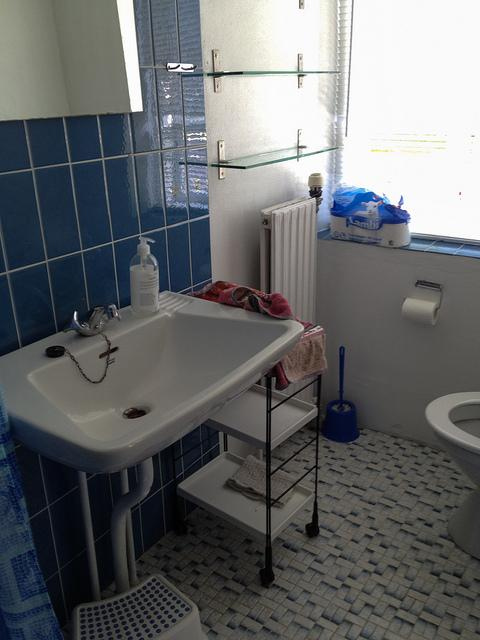What is usually done here? Please explain your reasoning. teeth brushing. The teeth are brushed. 